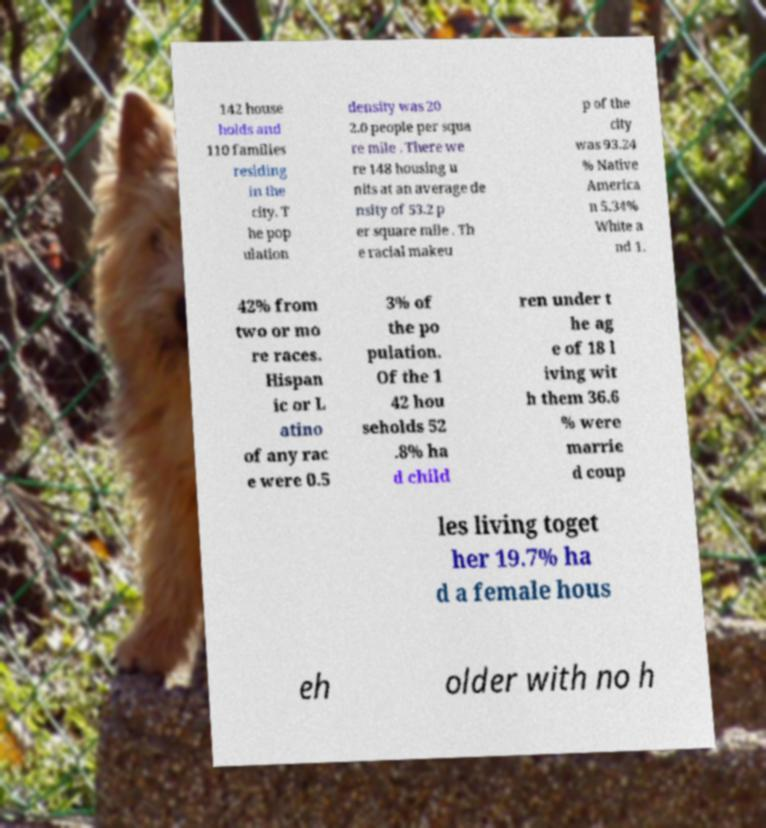Can you accurately transcribe the text from the provided image for me? 142 house holds and 110 families residing in the city. T he pop ulation density was 20 2.0 people per squa re mile . There we re 148 housing u nits at an average de nsity of 53.2 p er square mile . Th e racial makeu p of the city was 93.24 % Native America n 5.34% White a nd 1. 42% from two or mo re races. Hispan ic or L atino of any rac e were 0.5 3% of the po pulation. Of the 1 42 hou seholds 52 .8% ha d child ren under t he ag e of 18 l iving wit h them 36.6 % were marrie d coup les living toget her 19.7% ha d a female hous eh older with no h 